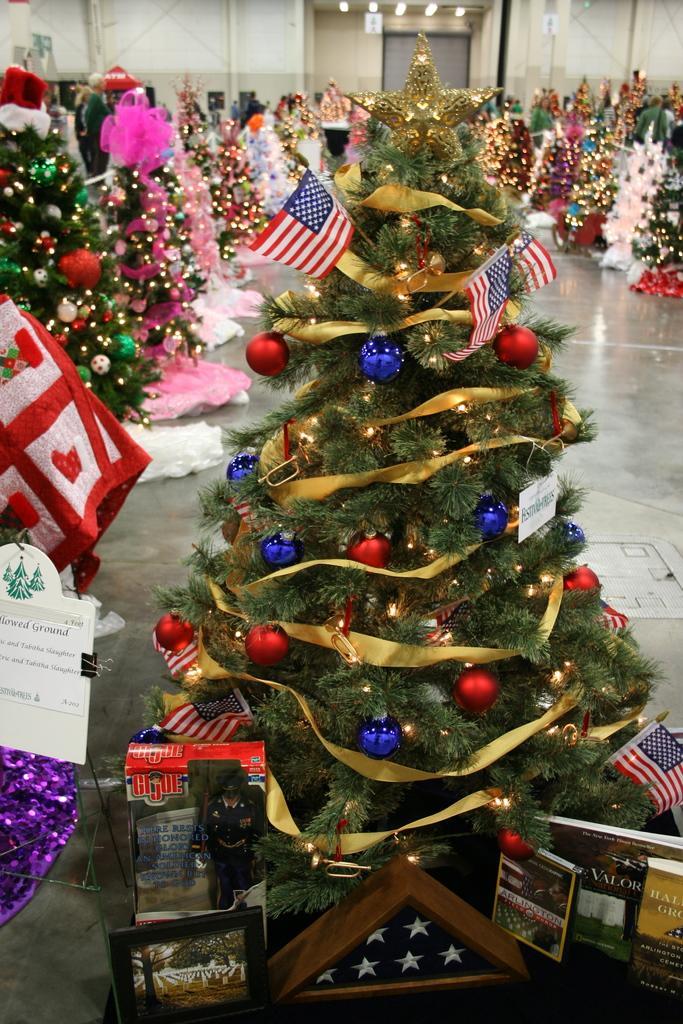Can you describe this image briefly? In this image I can see few Christmas trees around. Christmas trees are decorated with colorful balls, lights, books, flags and few decorative objects. Back I can see the white and cream wall. 